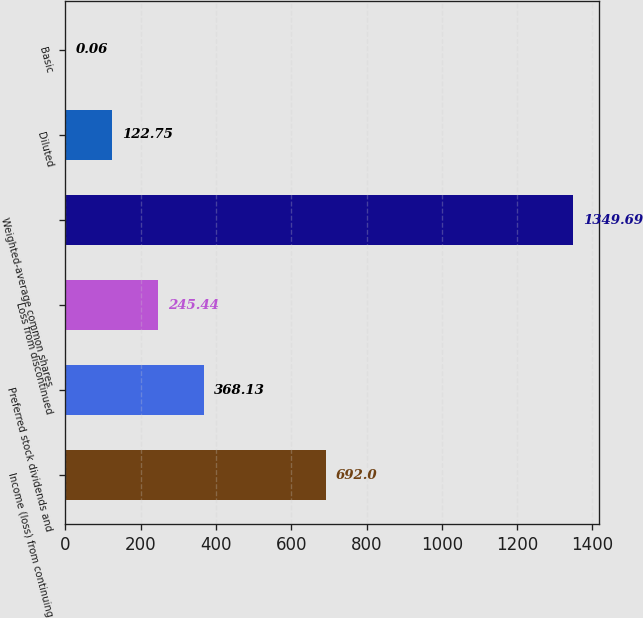Convert chart. <chart><loc_0><loc_0><loc_500><loc_500><bar_chart><fcel>Income (loss) from continuing<fcel>Preferred stock dividends and<fcel>Loss from discontinued<fcel>Weighted-average common shares<fcel>Diluted<fcel>Basic<nl><fcel>692<fcel>368.13<fcel>245.44<fcel>1349.69<fcel>122.75<fcel>0.06<nl></chart> 